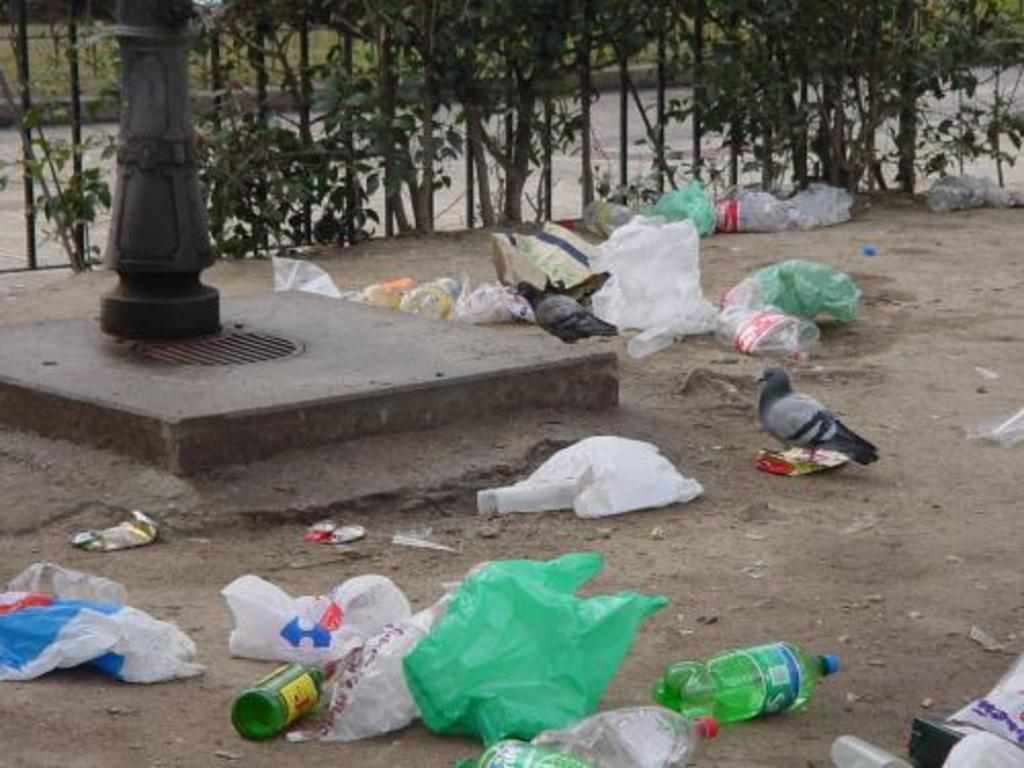What type of animals can be seen in the image? There are birds in the image. What objects are covering something in the image? There are plastic covers in the image. What type of containers are visible in the image? There are bottles in the image. What is on the ground in the image? There are objects on the ground in the image. What architectural feature can be seen in the image? There is a pillar in the image. What can be seen in the background of the image? There are trees, a road, and grass in the background of the image. What type of flowers can be seen in the image? There are no flowers visible in the image. 